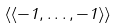Convert formula to latex. <formula><loc_0><loc_0><loc_500><loc_500>\langle \langle - 1 , \dots , - 1 \rangle \rangle</formula> 